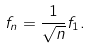Convert formula to latex. <formula><loc_0><loc_0><loc_500><loc_500>f _ { n } = \frac { 1 } { \sqrt { n } } f _ { 1 } .</formula> 